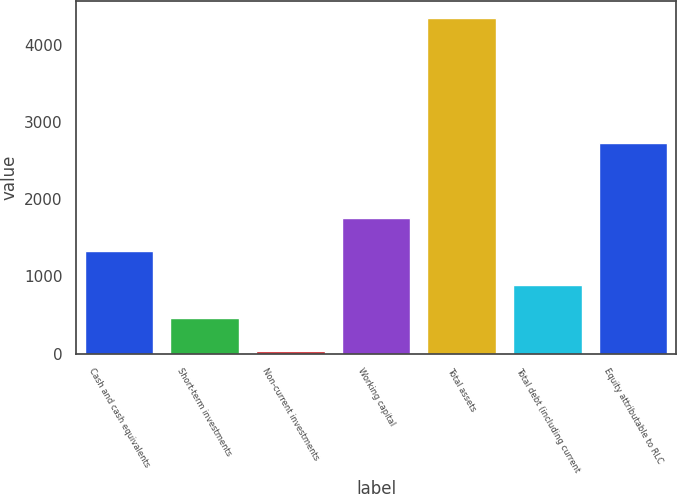Convert chart to OTSL. <chart><loc_0><loc_0><loc_500><loc_500><bar_chart><fcel>Cash and cash equivalents<fcel>Short-term investments<fcel>Non-current investments<fcel>Working capital<fcel>Total assets<fcel>Total debt (including current<fcel>Equity attributable to RLC<nl><fcel>1327.74<fcel>462.38<fcel>29.7<fcel>1760.42<fcel>4356.5<fcel>895.06<fcel>2735.1<nl></chart> 